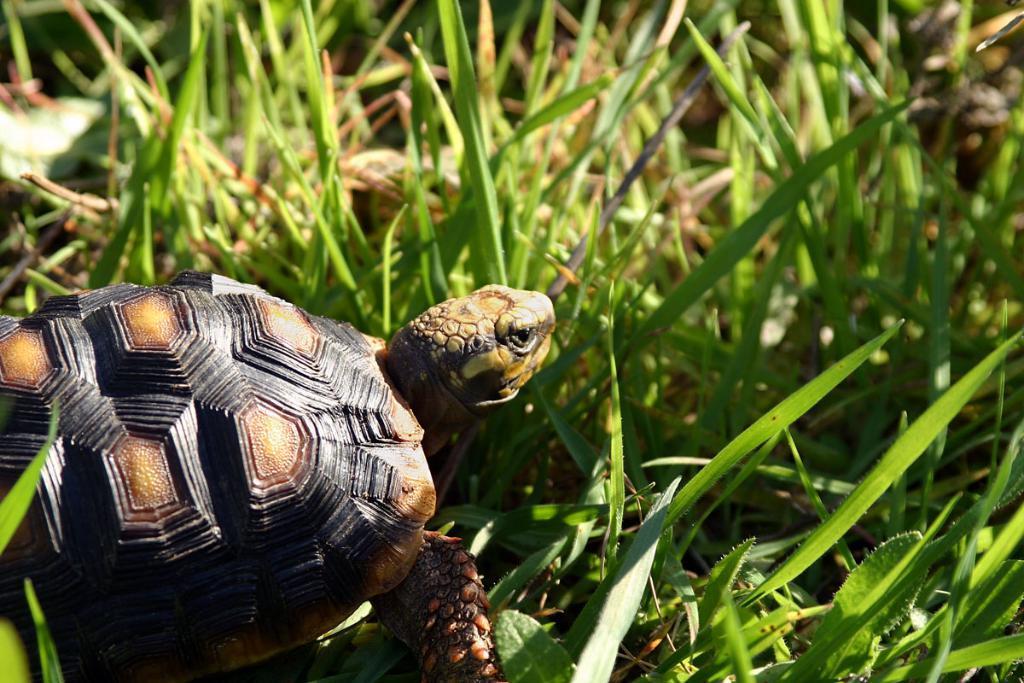Please provide a concise description of this image. In this image I can see a tortoise which is in brown and black color. In front I can see a green grass. 